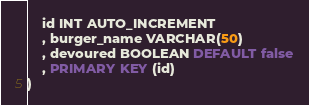<code> <loc_0><loc_0><loc_500><loc_500><_SQL_>	id INT AUTO_INCREMENT
    , burger_name VARCHAR(50)
    , devoured BOOLEAN DEFAULT false
    , PRIMARY KEY (id)
)</code> 